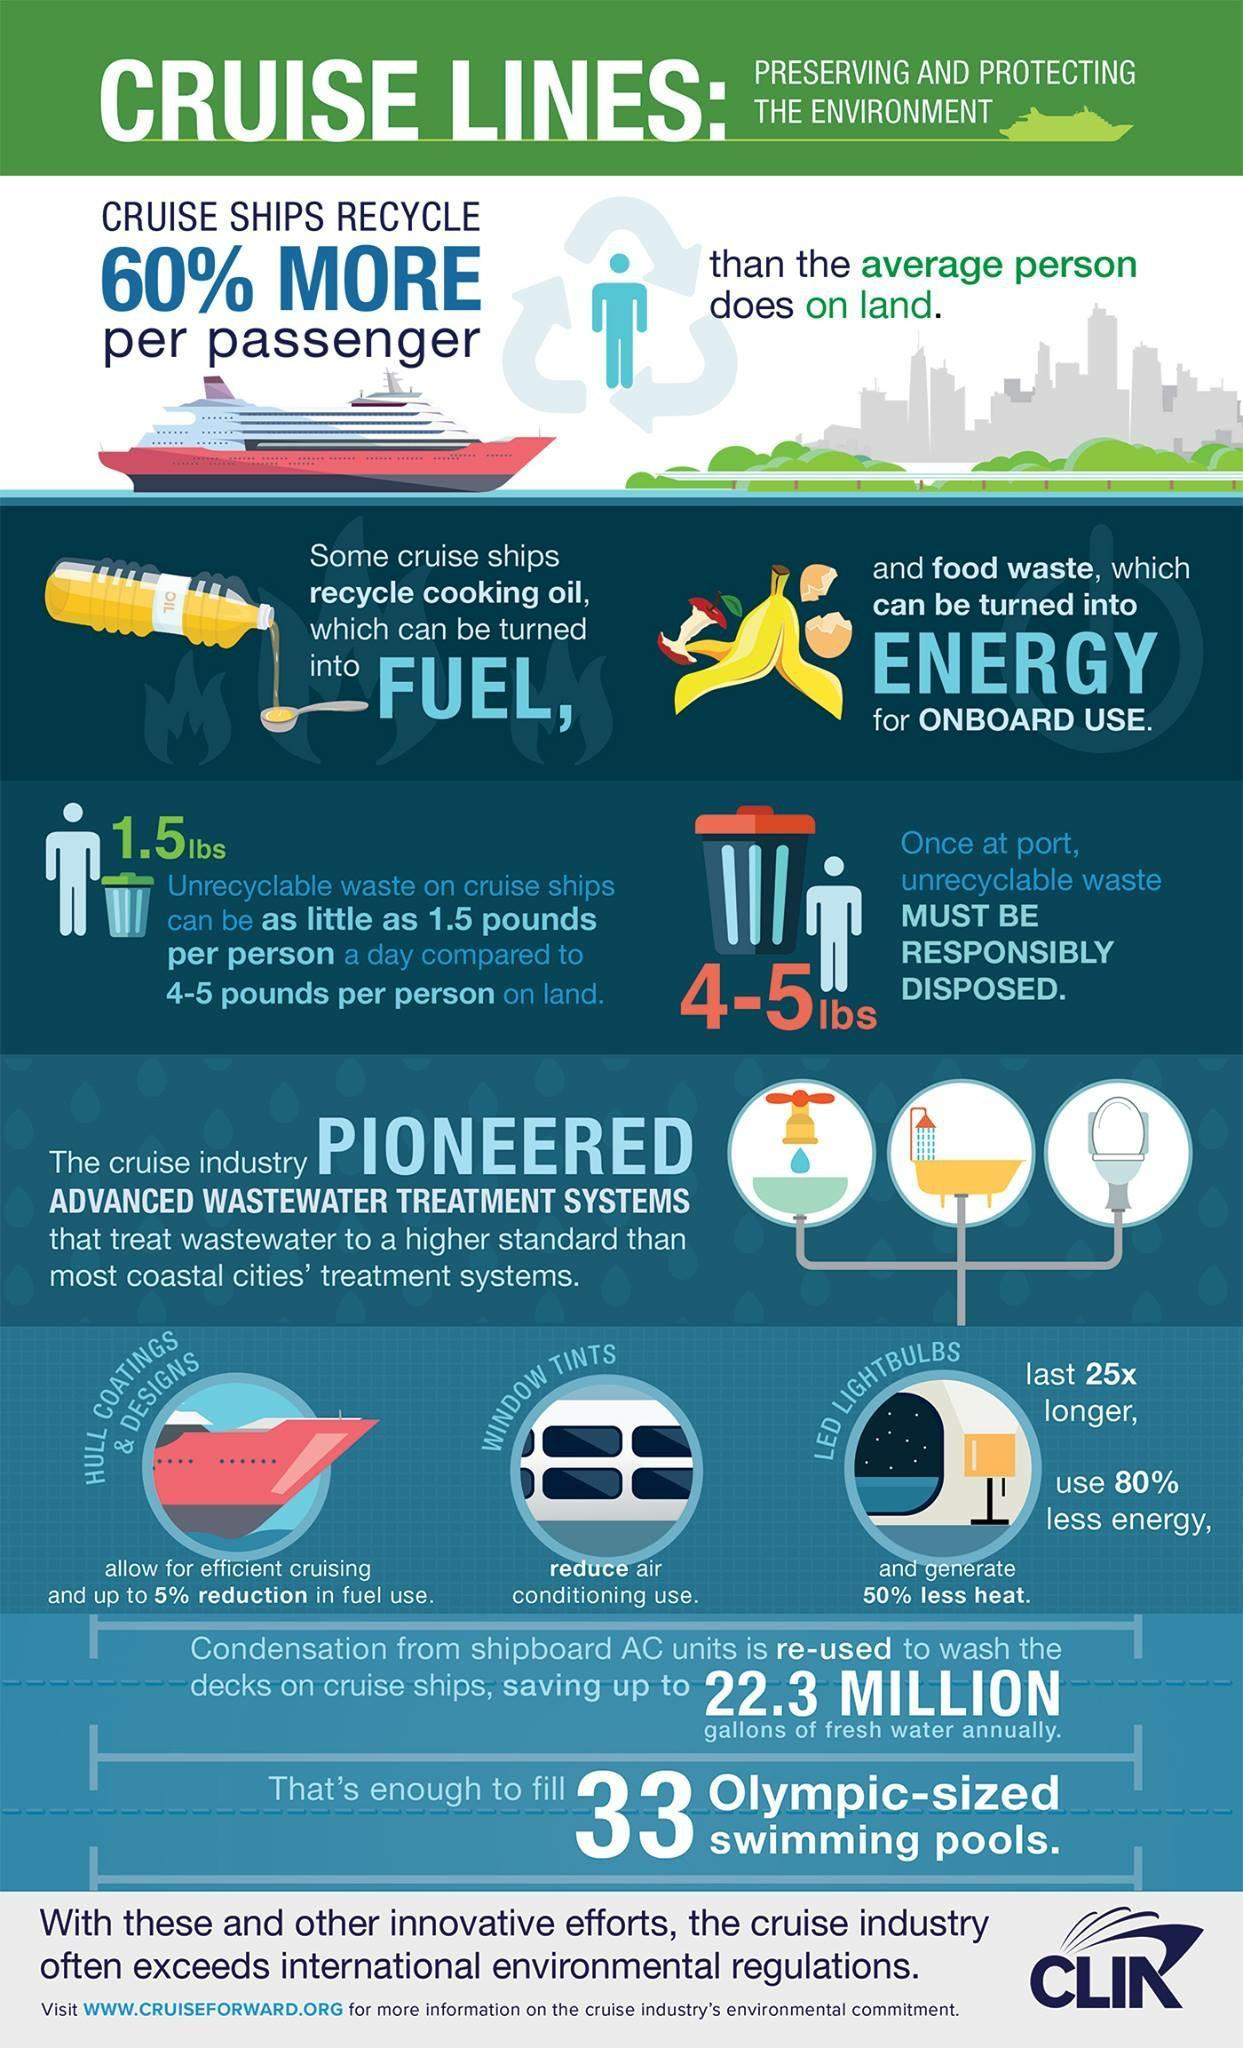Which factor reduces air conditioning use?
Answer the question with a short phrase. Window tints Which factor allows efficient cruising? Hull Coatings & Designs 